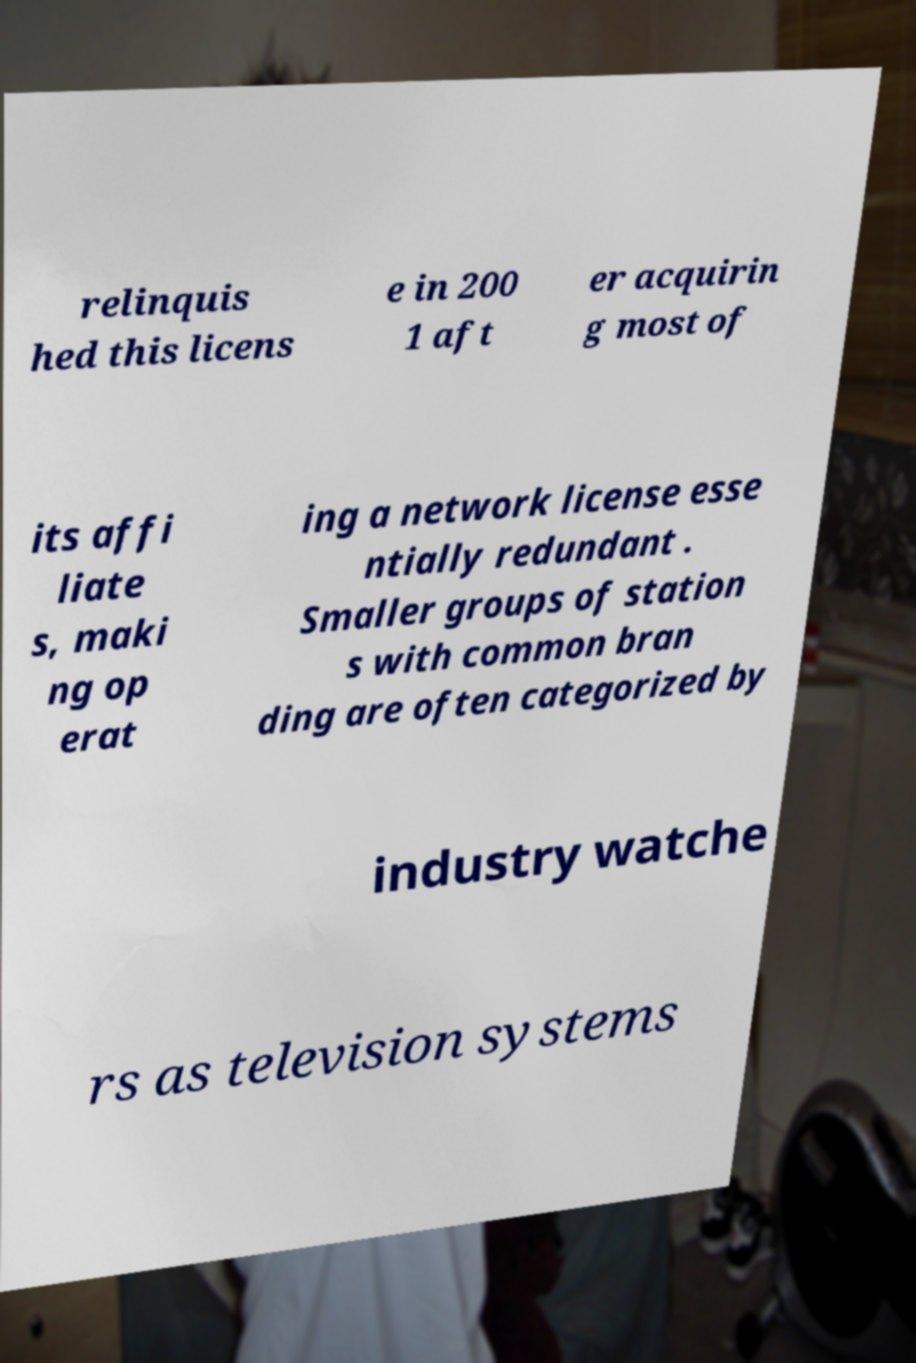For documentation purposes, I need the text within this image transcribed. Could you provide that? relinquis hed this licens e in 200 1 aft er acquirin g most of its affi liate s, maki ng op erat ing a network license esse ntially redundant . Smaller groups of station s with common bran ding are often categorized by industry watche rs as television systems 